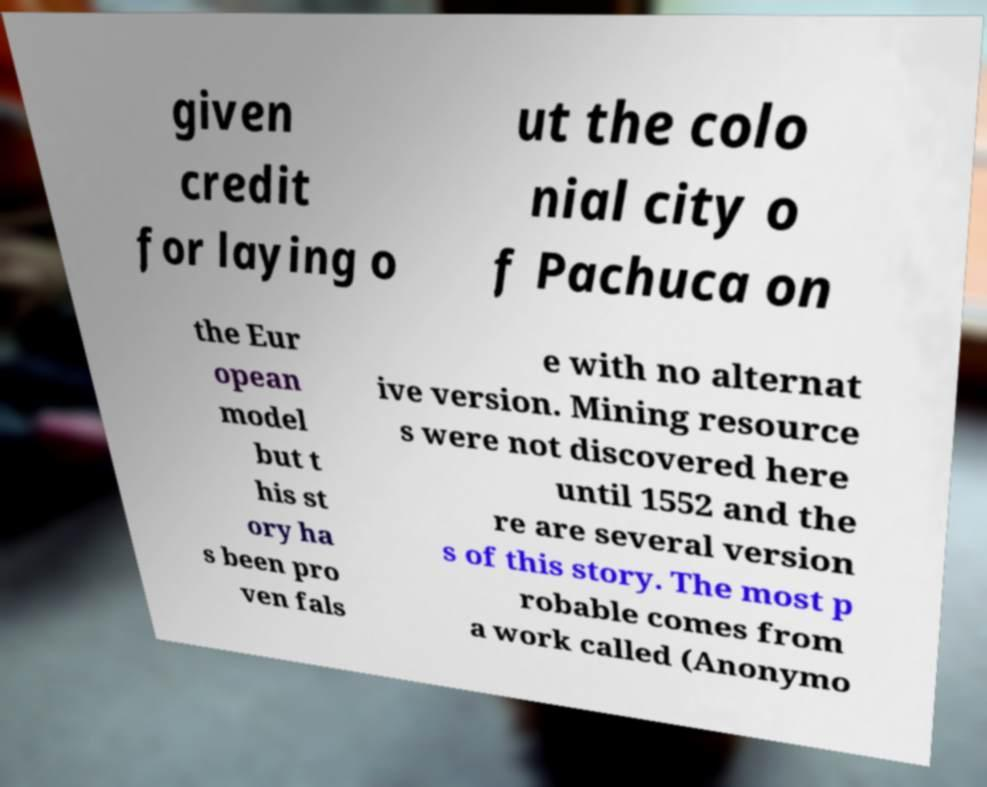Could you extract and type out the text from this image? given credit for laying o ut the colo nial city o f Pachuca on the Eur opean model but t his st ory ha s been pro ven fals e with no alternat ive version. Mining resource s were not discovered here until 1552 and the re are several version s of this story. The most p robable comes from a work called (Anonymo 